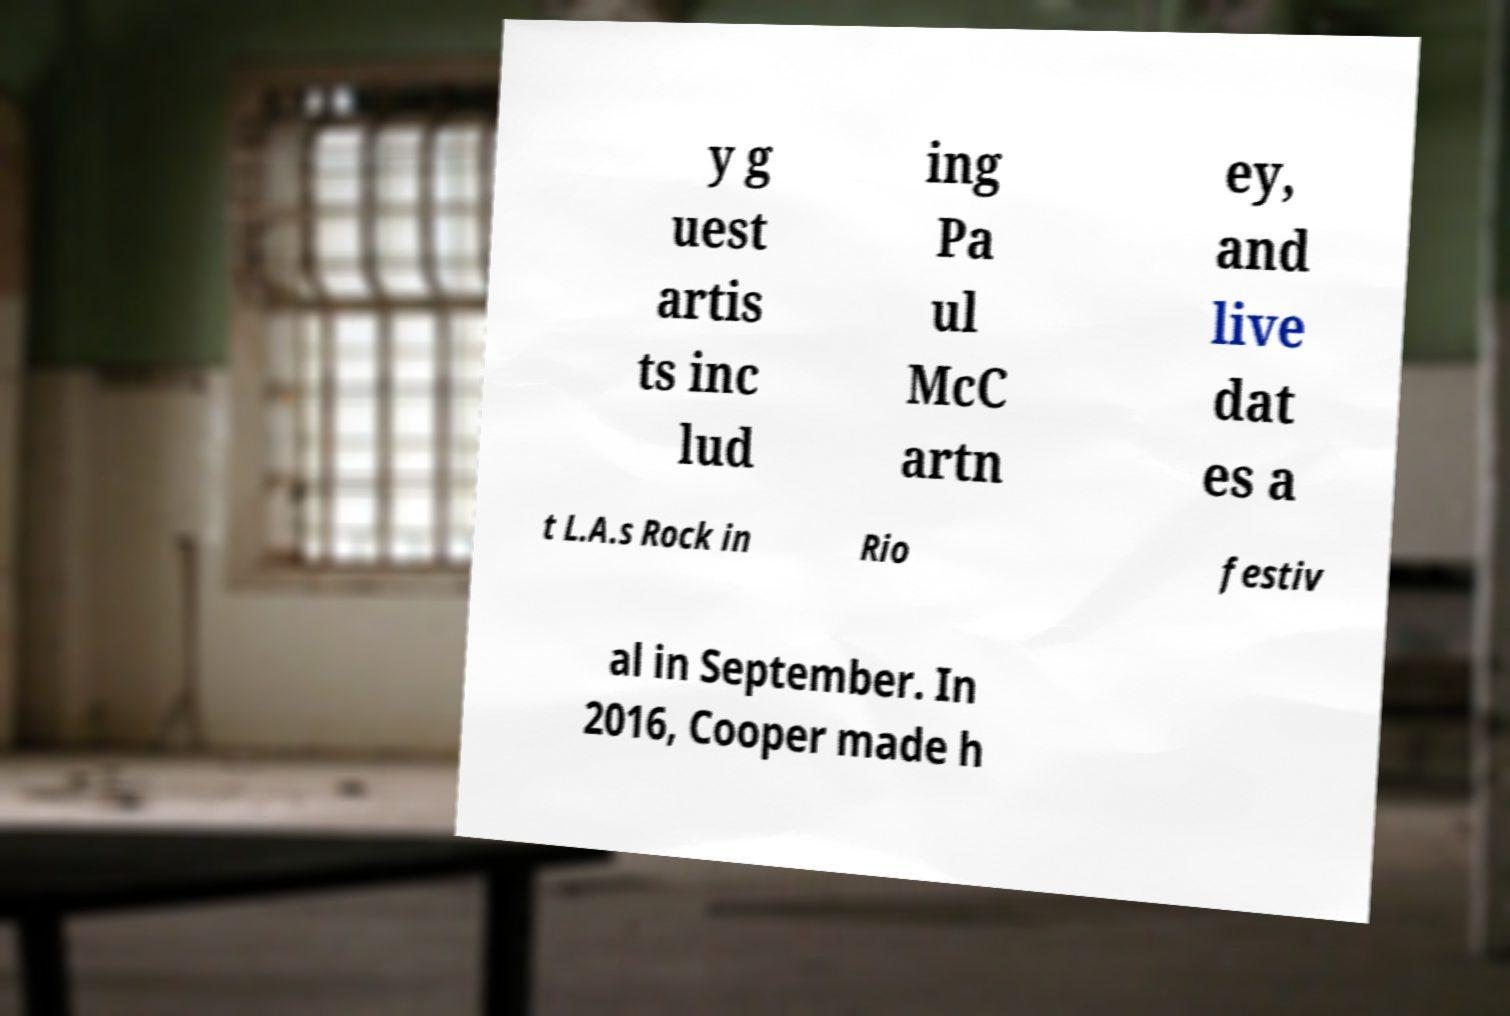There's text embedded in this image that I need extracted. Can you transcribe it verbatim? y g uest artis ts inc lud ing Pa ul McC artn ey, and live dat es a t L.A.s Rock in Rio festiv al in September. In 2016, Cooper made h 